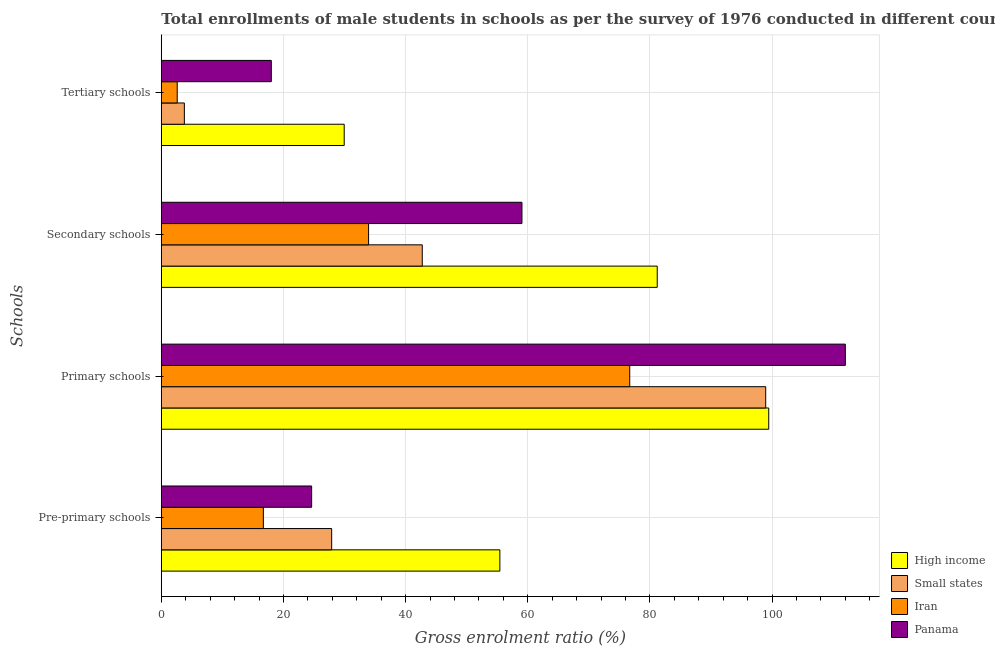How many different coloured bars are there?
Your response must be concise. 4. Are the number of bars per tick equal to the number of legend labels?
Give a very brief answer. Yes. How many bars are there on the 4th tick from the top?
Make the answer very short. 4. What is the label of the 1st group of bars from the top?
Give a very brief answer. Tertiary schools. What is the gross enrolment ratio(male) in tertiary schools in High income?
Provide a succinct answer. 29.95. Across all countries, what is the maximum gross enrolment ratio(male) in secondary schools?
Your response must be concise. 81.2. Across all countries, what is the minimum gross enrolment ratio(male) in primary schools?
Offer a very short reply. 76.7. In which country was the gross enrolment ratio(male) in pre-primary schools maximum?
Offer a very short reply. High income. In which country was the gross enrolment ratio(male) in pre-primary schools minimum?
Your answer should be compact. Iran. What is the total gross enrolment ratio(male) in tertiary schools in the graph?
Your answer should be very brief. 54.33. What is the difference between the gross enrolment ratio(male) in primary schools in Small states and that in Iran?
Give a very brief answer. 22.26. What is the difference between the gross enrolment ratio(male) in tertiary schools in Small states and the gross enrolment ratio(male) in pre-primary schools in High income?
Provide a succinct answer. -51.66. What is the average gross enrolment ratio(male) in tertiary schools per country?
Your response must be concise. 13.58. What is the difference between the gross enrolment ratio(male) in secondary schools and gross enrolment ratio(male) in pre-primary schools in Iran?
Keep it short and to the point. 17.23. In how many countries, is the gross enrolment ratio(male) in secondary schools greater than 112 %?
Offer a terse response. 0. What is the ratio of the gross enrolment ratio(male) in tertiary schools in Panama to that in Small states?
Offer a terse response. 4.77. What is the difference between the highest and the second highest gross enrolment ratio(male) in secondary schools?
Keep it short and to the point. 22.15. What is the difference between the highest and the lowest gross enrolment ratio(male) in pre-primary schools?
Give a very brief answer. 38.72. Is the sum of the gross enrolment ratio(male) in primary schools in Iran and Small states greater than the maximum gross enrolment ratio(male) in tertiary schools across all countries?
Make the answer very short. Yes. What does the 4th bar from the top in Secondary schools represents?
Your answer should be very brief. High income. What does the 3rd bar from the bottom in Pre-primary schools represents?
Provide a succinct answer. Iran. Is it the case that in every country, the sum of the gross enrolment ratio(male) in pre-primary schools and gross enrolment ratio(male) in primary schools is greater than the gross enrolment ratio(male) in secondary schools?
Your response must be concise. Yes. How many bars are there?
Give a very brief answer. 16. How many countries are there in the graph?
Offer a terse response. 4. Does the graph contain any zero values?
Your answer should be very brief. No. Where does the legend appear in the graph?
Make the answer very short. Bottom right. How many legend labels are there?
Your answer should be compact. 4. What is the title of the graph?
Offer a terse response. Total enrollments of male students in schools as per the survey of 1976 conducted in different countries. Does "St. Kitts and Nevis" appear as one of the legend labels in the graph?
Your answer should be compact. No. What is the label or title of the Y-axis?
Provide a short and direct response. Schools. What is the Gross enrolment ratio (%) in High income in Pre-primary schools?
Offer a terse response. 55.43. What is the Gross enrolment ratio (%) of Small states in Pre-primary schools?
Keep it short and to the point. 27.89. What is the Gross enrolment ratio (%) in Iran in Pre-primary schools?
Offer a terse response. 16.71. What is the Gross enrolment ratio (%) of Panama in Pre-primary schools?
Make the answer very short. 24.62. What is the Gross enrolment ratio (%) of High income in Primary schools?
Provide a succinct answer. 99.46. What is the Gross enrolment ratio (%) in Small states in Primary schools?
Your response must be concise. 98.96. What is the Gross enrolment ratio (%) of Iran in Primary schools?
Keep it short and to the point. 76.7. What is the Gross enrolment ratio (%) of Panama in Primary schools?
Provide a short and direct response. 112. What is the Gross enrolment ratio (%) of High income in Secondary schools?
Keep it short and to the point. 81.2. What is the Gross enrolment ratio (%) of Small states in Secondary schools?
Your answer should be compact. 42.73. What is the Gross enrolment ratio (%) in Iran in Secondary schools?
Provide a short and direct response. 33.94. What is the Gross enrolment ratio (%) of Panama in Secondary schools?
Make the answer very short. 59.05. What is the Gross enrolment ratio (%) of High income in Tertiary schools?
Ensure brevity in your answer.  29.95. What is the Gross enrolment ratio (%) in Small states in Tertiary schools?
Your response must be concise. 3.77. What is the Gross enrolment ratio (%) in Iran in Tertiary schools?
Make the answer very short. 2.61. What is the Gross enrolment ratio (%) in Panama in Tertiary schools?
Provide a short and direct response. 18.01. Across all Schools, what is the maximum Gross enrolment ratio (%) of High income?
Provide a short and direct response. 99.46. Across all Schools, what is the maximum Gross enrolment ratio (%) in Small states?
Keep it short and to the point. 98.96. Across all Schools, what is the maximum Gross enrolment ratio (%) of Iran?
Offer a very short reply. 76.7. Across all Schools, what is the maximum Gross enrolment ratio (%) in Panama?
Offer a terse response. 112. Across all Schools, what is the minimum Gross enrolment ratio (%) in High income?
Provide a short and direct response. 29.95. Across all Schools, what is the minimum Gross enrolment ratio (%) in Small states?
Offer a terse response. 3.77. Across all Schools, what is the minimum Gross enrolment ratio (%) of Iran?
Your answer should be very brief. 2.61. Across all Schools, what is the minimum Gross enrolment ratio (%) of Panama?
Your answer should be compact. 18.01. What is the total Gross enrolment ratio (%) in High income in the graph?
Your response must be concise. 266.04. What is the total Gross enrolment ratio (%) in Small states in the graph?
Make the answer very short. 173.36. What is the total Gross enrolment ratio (%) of Iran in the graph?
Keep it short and to the point. 129.95. What is the total Gross enrolment ratio (%) in Panama in the graph?
Offer a very short reply. 213.67. What is the difference between the Gross enrolment ratio (%) of High income in Pre-primary schools and that in Primary schools?
Offer a very short reply. -44.03. What is the difference between the Gross enrolment ratio (%) of Small states in Pre-primary schools and that in Primary schools?
Your response must be concise. -71.07. What is the difference between the Gross enrolment ratio (%) in Iran in Pre-primary schools and that in Primary schools?
Give a very brief answer. -59.99. What is the difference between the Gross enrolment ratio (%) in Panama in Pre-primary schools and that in Primary schools?
Give a very brief answer. -87.38. What is the difference between the Gross enrolment ratio (%) of High income in Pre-primary schools and that in Secondary schools?
Keep it short and to the point. -25.77. What is the difference between the Gross enrolment ratio (%) of Small states in Pre-primary schools and that in Secondary schools?
Offer a terse response. -14.83. What is the difference between the Gross enrolment ratio (%) in Iran in Pre-primary schools and that in Secondary schools?
Give a very brief answer. -17.23. What is the difference between the Gross enrolment ratio (%) of Panama in Pre-primary schools and that in Secondary schools?
Provide a succinct answer. -34.44. What is the difference between the Gross enrolment ratio (%) in High income in Pre-primary schools and that in Tertiary schools?
Keep it short and to the point. 25.49. What is the difference between the Gross enrolment ratio (%) in Small states in Pre-primary schools and that in Tertiary schools?
Offer a very short reply. 24.12. What is the difference between the Gross enrolment ratio (%) of Iran in Pre-primary schools and that in Tertiary schools?
Your response must be concise. 14.1. What is the difference between the Gross enrolment ratio (%) in Panama in Pre-primary schools and that in Tertiary schools?
Make the answer very short. 6.61. What is the difference between the Gross enrolment ratio (%) in High income in Primary schools and that in Secondary schools?
Offer a very short reply. 18.26. What is the difference between the Gross enrolment ratio (%) of Small states in Primary schools and that in Secondary schools?
Your answer should be very brief. 56.23. What is the difference between the Gross enrolment ratio (%) in Iran in Primary schools and that in Secondary schools?
Your answer should be compact. 42.76. What is the difference between the Gross enrolment ratio (%) in Panama in Primary schools and that in Secondary schools?
Provide a short and direct response. 52.95. What is the difference between the Gross enrolment ratio (%) of High income in Primary schools and that in Tertiary schools?
Your answer should be very brief. 69.51. What is the difference between the Gross enrolment ratio (%) in Small states in Primary schools and that in Tertiary schools?
Ensure brevity in your answer.  95.19. What is the difference between the Gross enrolment ratio (%) in Iran in Primary schools and that in Tertiary schools?
Your answer should be very brief. 74.09. What is the difference between the Gross enrolment ratio (%) of Panama in Primary schools and that in Tertiary schools?
Offer a terse response. 93.99. What is the difference between the Gross enrolment ratio (%) of High income in Secondary schools and that in Tertiary schools?
Your response must be concise. 51.26. What is the difference between the Gross enrolment ratio (%) in Small states in Secondary schools and that in Tertiary schools?
Your answer should be very brief. 38.96. What is the difference between the Gross enrolment ratio (%) of Iran in Secondary schools and that in Tertiary schools?
Provide a short and direct response. 31.33. What is the difference between the Gross enrolment ratio (%) in Panama in Secondary schools and that in Tertiary schools?
Ensure brevity in your answer.  41.04. What is the difference between the Gross enrolment ratio (%) of High income in Pre-primary schools and the Gross enrolment ratio (%) of Small states in Primary schools?
Provide a short and direct response. -43.53. What is the difference between the Gross enrolment ratio (%) of High income in Pre-primary schools and the Gross enrolment ratio (%) of Iran in Primary schools?
Provide a succinct answer. -21.27. What is the difference between the Gross enrolment ratio (%) of High income in Pre-primary schools and the Gross enrolment ratio (%) of Panama in Primary schools?
Ensure brevity in your answer.  -56.57. What is the difference between the Gross enrolment ratio (%) of Small states in Pre-primary schools and the Gross enrolment ratio (%) of Iran in Primary schools?
Your answer should be compact. -48.81. What is the difference between the Gross enrolment ratio (%) of Small states in Pre-primary schools and the Gross enrolment ratio (%) of Panama in Primary schools?
Give a very brief answer. -84.11. What is the difference between the Gross enrolment ratio (%) in Iran in Pre-primary schools and the Gross enrolment ratio (%) in Panama in Primary schools?
Give a very brief answer. -95.29. What is the difference between the Gross enrolment ratio (%) of High income in Pre-primary schools and the Gross enrolment ratio (%) of Small states in Secondary schools?
Your answer should be compact. 12.7. What is the difference between the Gross enrolment ratio (%) of High income in Pre-primary schools and the Gross enrolment ratio (%) of Iran in Secondary schools?
Keep it short and to the point. 21.49. What is the difference between the Gross enrolment ratio (%) in High income in Pre-primary schools and the Gross enrolment ratio (%) in Panama in Secondary schools?
Provide a short and direct response. -3.62. What is the difference between the Gross enrolment ratio (%) in Small states in Pre-primary schools and the Gross enrolment ratio (%) in Iran in Secondary schools?
Make the answer very short. -6.04. What is the difference between the Gross enrolment ratio (%) of Small states in Pre-primary schools and the Gross enrolment ratio (%) of Panama in Secondary schools?
Make the answer very short. -31.16. What is the difference between the Gross enrolment ratio (%) in Iran in Pre-primary schools and the Gross enrolment ratio (%) in Panama in Secondary schools?
Offer a very short reply. -42.34. What is the difference between the Gross enrolment ratio (%) in High income in Pre-primary schools and the Gross enrolment ratio (%) in Small states in Tertiary schools?
Provide a succinct answer. 51.66. What is the difference between the Gross enrolment ratio (%) of High income in Pre-primary schools and the Gross enrolment ratio (%) of Iran in Tertiary schools?
Your answer should be very brief. 52.83. What is the difference between the Gross enrolment ratio (%) in High income in Pre-primary schools and the Gross enrolment ratio (%) in Panama in Tertiary schools?
Offer a terse response. 37.42. What is the difference between the Gross enrolment ratio (%) of Small states in Pre-primary schools and the Gross enrolment ratio (%) of Iran in Tertiary schools?
Ensure brevity in your answer.  25.29. What is the difference between the Gross enrolment ratio (%) of Small states in Pre-primary schools and the Gross enrolment ratio (%) of Panama in Tertiary schools?
Ensure brevity in your answer.  9.88. What is the difference between the Gross enrolment ratio (%) of Iran in Pre-primary schools and the Gross enrolment ratio (%) of Panama in Tertiary schools?
Provide a short and direct response. -1.3. What is the difference between the Gross enrolment ratio (%) in High income in Primary schools and the Gross enrolment ratio (%) in Small states in Secondary schools?
Provide a short and direct response. 56.73. What is the difference between the Gross enrolment ratio (%) in High income in Primary schools and the Gross enrolment ratio (%) in Iran in Secondary schools?
Offer a very short reply. 65.52. What is the difference between the Gross enrolment ratio (%) in High income in Primary schools and the Gross enrolment ratio (%) in Panama in Secondary schools?
Give a very brief answer. 40.41. What is the difference between the Gross enrolment ratio (%) in Small states in Primary schools and the Gross enrolment ratio (%) in Iran in Secondary schools?
Keep it short and to the point. 65.02. What is the difference between the Gross enrolment ratio (%) in Small states in Primary schools and the Gross enrolment ratio (%) in Panama in Secondary schools?
Your answer should be compact. 39.91. What is the difference between the Gross enrolment ratio (%) in Iran in Primary schools and the Gross enrolment ratio (%) in Panama in Secondary schools?
Ensure brevity in your answer.  17.65. What is the difference between the Gross enrolment ratio (%) of High income in Primary schools and the Gross enrolment ratio (%) of Small states in Tertiary schools?
Provide a short and direct response. 95.69. What is the difference between the Gross enrolment ratio (%) of High income in Primary schools and the Gross enrolment ratio (%) of Iran in Tertiary schools?
Your answer should be very brief. 96.85. What is the difference between the Gross enrolment ratio (%) in High income in Primary schools and the Gross enrolment ratio (%) in Panama in Tertiary schools?
Provide a succinct answer. 81.45. What is the difference between the Gross enrolment ratio (%) of Small states in Primary schools and the Gross enrolment ratio (%) of Iran in Tertiary schools?
Make the answer very short. 96.36. What is the difference between the Gross enrolment ratio (%) of Small states in Primary schools and the Gross enrolment ratio (%) of Panama in Tertiary schools?
Make the answer very short. 80.95. What is the difference between the Gross enrolment ratio (%) in Iran in Primary schools and the Gross enrolment ratio (%) in Panama in Tertiary schools?
Keep it short and to the point. 58.69. What is the difference between the Gross enrolment ratio (%) in High income in Secondary schools and the Gross enrolment ratio (%) in Small states in Tertiary schools?
Ensure brevity in your answer.  77.43. What is the difference between the Gross enrolment ratio (%) in High income in Secondary schools and the Gross enrolment ratio (%) in Iran in Tertiary schools?
Offer a terse response. 78.6. What is the difference between the Gross enrolment ratio (%) in High income in Secondary schools and the Gross enrolment ratio (%) in Panama in Tertiary schools?
Ensure brevity in your answer.  63.19. What is the difference between the Gross enrolment ratio (%) in Small states in Secondary schools and the Gross enrolment ratio (%) in Iran in Tertiary schools?
Give a very brief answer. 40.12. What is the difference between the Gross enrolment ratio (%) in Small states in Secondary schools and the Gross enrolment ratio (%) in Panama in Tertiary schools?
Your answer should be very brief. 24.72. What is the difference between the Gross enrolment ratio (%) of Iran in Secondary schools and the Gross enrolment ratio (%) of Panama in Tertiary schools?
Offer a terse response. 15.93. What is the average Gross enrolment ratio (%) in High income per Schools?
Provide a succinct answer. 66.51. What is the average Gross enrolment ratio (%) of Small states per Schools?
Make the answer very short. 43.34. What is the average Gross enrolment ratio (%) of Iran per Schools?
Your response must be concise. 32.49. What is the average Gross enrolment ratio (%) of Panama per Schools?
Keep it short and to the point. 53.42. What is the difference between the Gross enrolment ratio (%) of High income and Gross enrolment ratio (%) of Small states in Pre-primary schools?
Your answer should be compact. 27.54. What is the difference between the Gross enrolment ratio (%) in High income and Gross enrolment ratio (%) in Iran in Pre-primary schools?
Provide a short and direct response. 38.72. What is the difference between the Gross enrolment ratio (%) in High income and Gross enrolment ratio (%) in Panama in Pre-primary schools?
Keep it short and to the point. 30.82. What is the difference between the Gross enrolment ratio (%) in Small states and Gross enrolment ratio (%) in Iran in Pre-primary schools?
Give a very brief answer. 11.19. What is the difference between the Gross enrolment ratio (%) of Small states and Gross enrolment ratio (%) of Panama in Pre-primary schools?
Your answer should be compact. 3.28. What is the difference between the Gross enrolment ratio (%) in Iran and Gross enrolment ratio (%) in Panama in Pre-primary schools?
Ensure brevity in your answer.  -7.91. What is the difference between the Gross enrolment ratio (%) in High income and Gross enrolment ratio (%) in Small states in Primary schools?
Offer a very short reply. 0.5. What is the difference between the Gross enrolment ratio (%) of High income and Gross enrolment ratio (%) of Iran in Primary schools?
Your answer should be compact. 22.76. What is the difference between the Gross enrolment ratio (%) of High income and Gross enrolment ratio (%) of Panama in Primary schools?
Keep it short and to the point. -12.54. What is the difference between the Gross enrolment ratio (%) in Small states and Gross enrolment ratio (%) in Iran in Primary schools?
Provide a succinct answer. 22.26. What is the difference between the Gross enrolment ratio (%) of Small states and Gross enrolment ratio (%) of Panama in Primary schools?
Your answer should be compact. -13.04. What is the difference between the Gross enrolment ratio (%) of Iran and Gross enrolment ratio (%) of Panama in Primary schools?
Provide a short and direct response. -35.3. What is the difference between the Gross enrolment ratio (%) of High income and Gross enrolment ratio (%) of Small states in Secondary schools?
Provide a succinct answer. 38.47. What is the difference between the Gross enrolment ratio (%) of High income and Gross enrolment ratio (%) of Iran in Secondary schools?
Offer a terse response. 47.26. What is the difference between the Gross enrolment ratio (%) of High income and Gross enrolment ratio (%) of Panama in Secondary schools?
Ensure brevity in your answer.  22.15. What is the difference between the Gross enrolment ratio (%) in Small states and Gross enrolment ratio (%) in Iran in Secondary schools?
Your answer should be very brief. 8.79. What is the difference between the Gross enrolment ratio (%) of Small states and Gross enrolment ratio (%) of Panama in Secondary schools?
Provide a succinct answer. -16.32. What is the difference between the Gross enrolment ratio (%) of Iran and Gross enrolment ratio (%) of Panama in Secondary schools?
Provide a short and direct response. -25.11. What is the difference between the Gross enrolment ratio (%) of High income and Gross enrolment ratio (%) of Small states in Tertiary schools?
Your response must be concise. 26.17. What is the difference between the Gross enrolment ratio (%) of High income and Gross enrolment ratio (%) of Iran in Tertiary schools?
Offer a very short reply. 27.34. What is the difference between the Gross enrolment ratio (%) of High income and Gross enrolment ratio (%) of Panama in Tertiary schools?
Your answer should be very brief. 11.94. What is the difference between the Gross enrolment ratio (%) of Small states and Gross enrolment ratio (%) of Iran in Tertiary schools?
Offer a terse response. 1.17. What is the difference between the Gross enrolment ratio (%) in Small states and Gross enrolment ratio (%) in Panama in Tertiary schools?
Your answer should be compact. -14.24. What is the difference between the Gross enrolment ratio (%) in Iran and Gross enrolment ratio (%) in Panama in Tertiary schools?
Ensure brevity in your answer.  -15.4. What is the ratio of the Gross enrolment ratio (%) of High income in Pre-primary schools to that in Primary schools?
Provide a short and direct response. 0.56. What is the ratio of the Gross enrolment ratio (%) in Small states in Pre-primary schools to that in Primary schools?
Offer a terse response. 0.28. What is the ratio of the Gross enrolment ratio (%) of Iran in Pre-primary schools to that in Primary schools?
Ensure brevity in your answer.  0.22. What is the ratio of the Gross enrolment ratio (%) of Panama in Pre-primary schools to that in Primary schools?
Keep it short and to the point. 0.22. What is the ratio of the Gross enrolment ratio (%) of High income in Pre-primary schools to that in Secondary schools?
Your response must be concise. 0.68. What is the ratio of the Gross enrolment ratio (%) in Small states in Pre-primary schools to that in Secondary schools?
Provide a short and direct response. 0.65. What is the ratio of the Gross enrolment ratio (%) of Iran in Pre-primary schools to that in Secondary schools?
Provide a short and direct response. 0.49. What is the ratio of the Gross enrolment ratio (%) in Panama in Pre-primary schools to that in Secondary schools?
Your answer should be very brief. 0.42. What is the ratio of the Gross enrolment ratio (%) of High income in Pre-primary schools to that in Tertiary schools?
Your answer should be very brief. 1.85. What is the ratio of the Gross enrolment ratio (%) in Small states in Pre-primary schools to that in Tertiary schools?
Your answer should be compact. 7.39. What is the ratio of the Gross enrolment ratio (%) in Iran in Pre-primary schools to that in Tertiary schools?
Keep it short and to the point. 6.41. What is the ratio of the Gross enrolment ratio (%) in Panama in Pre-primary schools to that in Tertiary schools?
Keep it short and to the point. 1.37. What is the ratio of the Gross enrolment ratio (%) of High income in Primary schools to that in Secondary schools?
Your answer should be compact. 1.22. What is the ratio of the Gross enrolment ratio (%) in Small states in Primary schools to that in Secondary schools?
Give a very brief answer. 2.32. What is the ratio of the Gross enrolment ratio (%) of Iran in Primary schools to that in Secondary schools?
Offer a terse response. 2.26. What is the ratio of the Gross enrolment ratio (%) in Panama in Primary schools to that in Secondary schools?
Your answer should be compact. 1.9. What is the ratio of the Gross enrolment ratio (%) of High income in Primary schools to that in Tertiary schools?
Your answer should be very brief. 3.32. What is the ratio of the Gross enrolment ratio (%) in Small states in Primary schools to that in Tertiary schools?
Your response must be concise. 26.23. What is the ratio of the Gross enrolment ratio (%) in Iran in Primary schools to that in Tertiary schools?
Your answer should be compact. 29.44. What is the ratio of the Gross enrolment ratio (%) of Panama in Primary schools to that in Tertiary schools?
Provide a short and direct response. 6.22. What is the ratio of the Gross enrolment ratio (%) in High income in Secondary schools to that in Tertiary schools?
Offer a terse response. 2.71. What is the ratio of the Gross enrolment ratio (%) in Small states in Secondary schools to that in Tertiary schools?
Make the answer very short. 11.33. What is the ratio of the Gross enrolment ratio (%) in Iran in Secondary schools to that in Tertiary schools?
Your response must be concise. 13.03. What is the ratio of the Gross enrolment ratio (%) of Panama in Secondary schools to that in Tertiary schools?
Keep it short and to the point. 3.28. What is the difference between the highest and the second highest Gross enrolment ratio (%) of High income?
Make the answer very short. 18.26. What is the difference between the highest and the second highest Gross enrolment ratio (%) of Small states?
Provide a short and direct response. 56.23. What is the difference between the highest and the second highest Gross enrolment ratio (%) in Iran?
Your response must be concise. 42.76. What is the difference between the highest and the second highest Gross enrolment ratio (%) in Panama?
Give a very brief answer. 52.95. What is the difference between the highest and the lowest Gross enrolment ratio (%) of High income?
Make the answer very short. 69.51. What is the difference between the highest and the lowest Gross enrolment ratio (%) of Small states?
Your answer should be very brief. 95.19. What is the difference between the highest and the lowest Gross enrolment ratio (%) in Iran?
Provide a succinct answer. 74.09. What is the difference between the highest and the lowest Gross enrolment ratio (%) of Panama?
Your answer should be very brief. 93.99. 